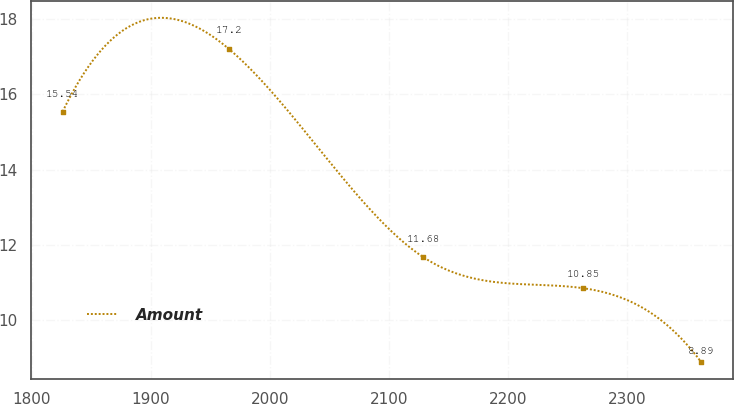Convert chart. <chart><loc_0><loc_0><loc_500><loc_500><line_chart><ecel><fcel>Amount<nl><fcel>1826.05<fcel>15.54<nl><fcel>1965.8<fcel>17.2<nl><fcel>2128.48<fcel>11.68<nl><fcel>2262.94<fcel>10.85<nl><fcel>2361.9<fcel>8.89<nl></chart> 